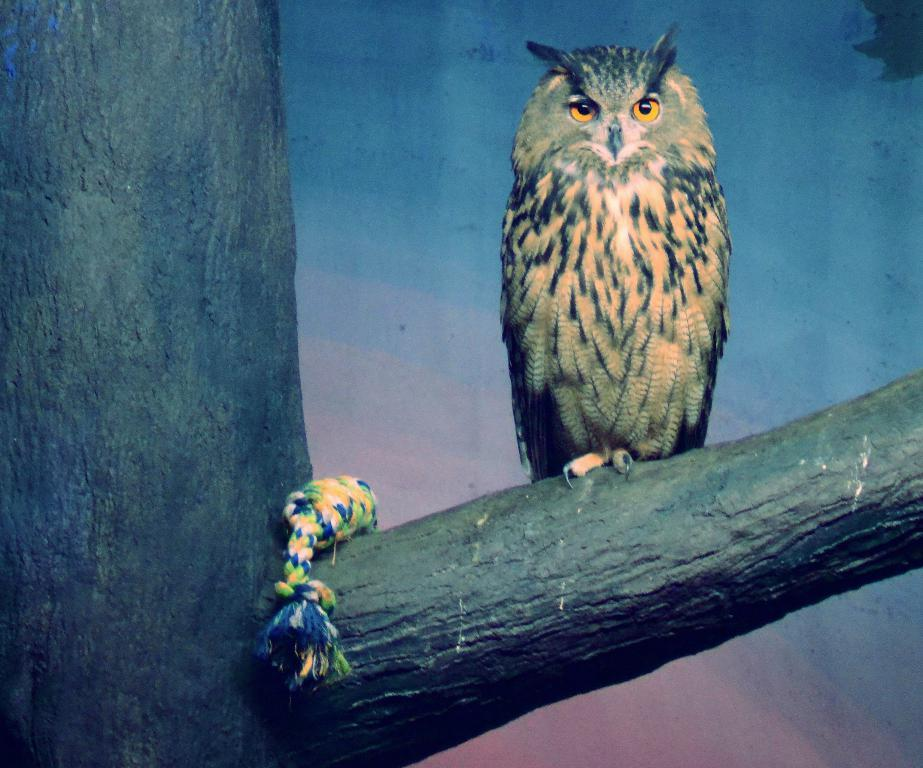What animal is in the picture? There is an owl in the picture. Where is the owl located? The owl is standing on a tree branch. What else can be seen in the picture besides the owl? There is a cloth visible in the picture. What can be seen in the background of the picture? The sky is visible in the background of the picture. How is the image presented? The picture appears to be a painting. What is the size of the quilt in the picture? There is no quilt present in the picture; it only features an owl on a tree branch, a cloth, and the sky in the background. 